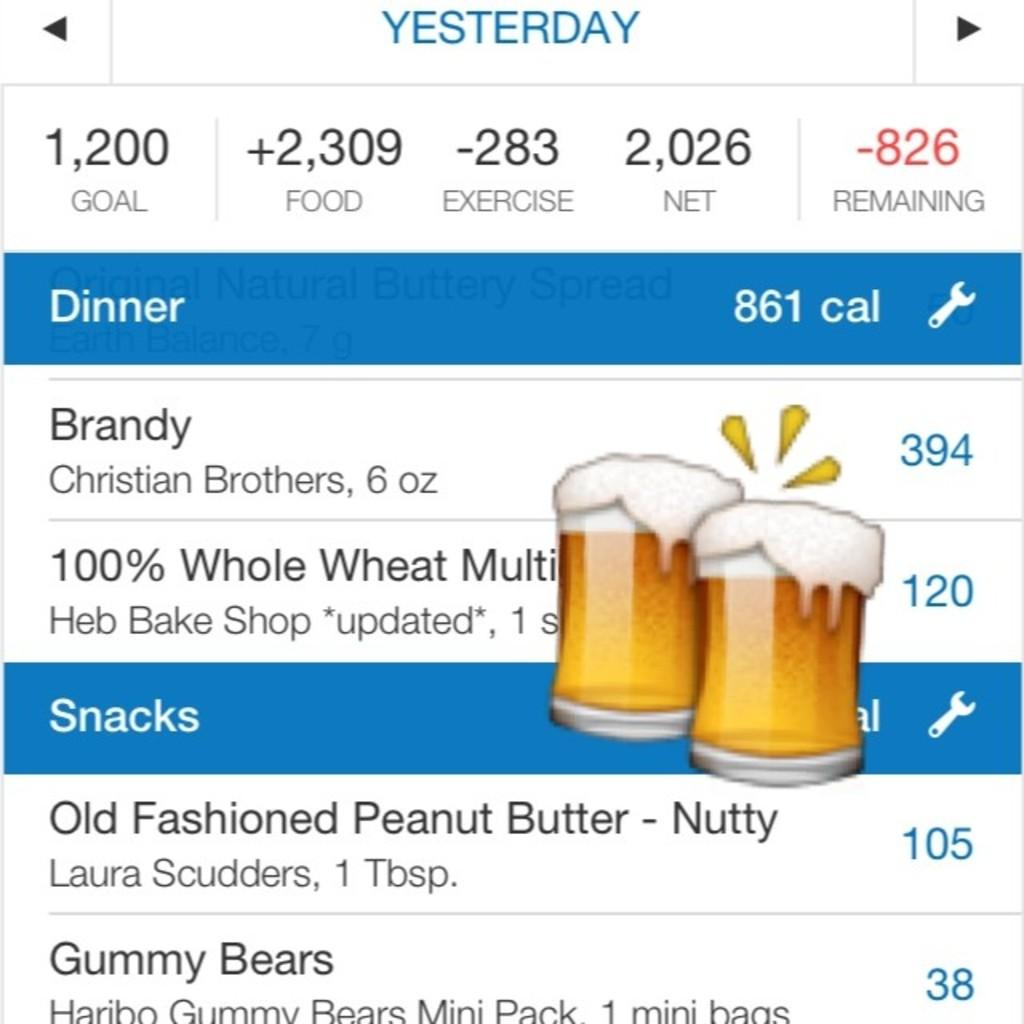<image>
Render a clear and concise summary of the photo. A listing of calories for various dinner and snack items including Brandy, gummy bears, and peanut butter, among others. 